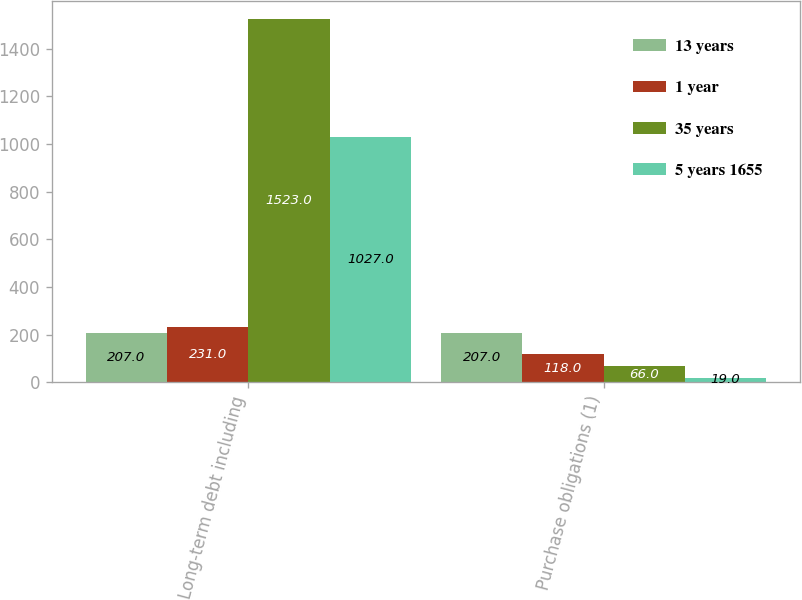Convert chart. <chart><loc_0><loc_0><loc_500><loc_500><stacked_bar_chart><ecel><fcel>Long-term debt including<fcel>Purchase obligations (1)<nl><fcel>13 years<fcel>207<fcel>207<nl><fcel>1 year<fcel>231<fcel>118<nl><fcel>35 years<fcel>1523<fcel>66<nl><fcel>5 years 1655<fcel>1027<fcel>19<nl></chart> 